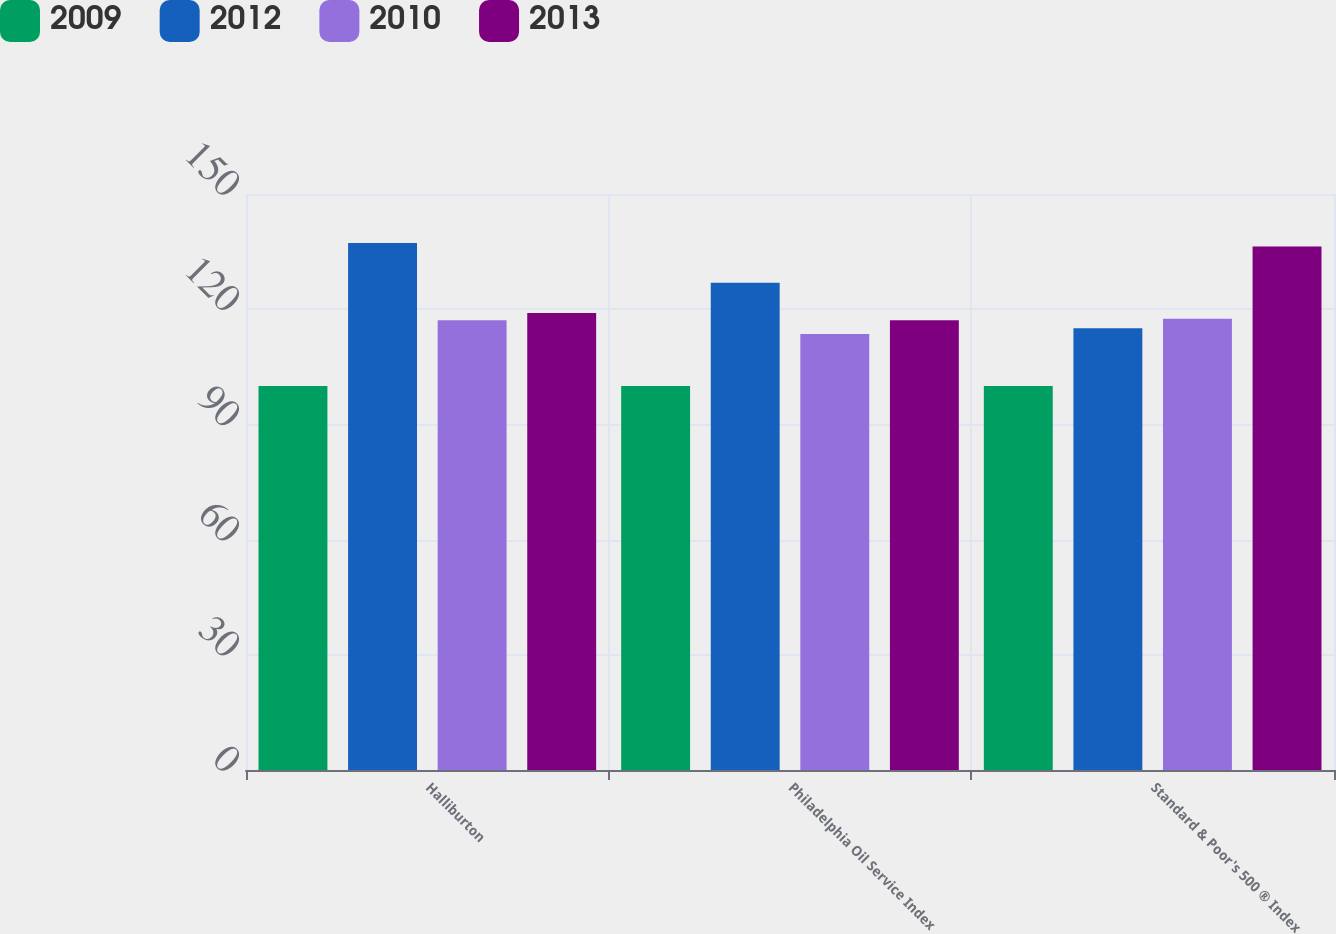Convert chart to OTSL. <chart><loc_0><loc_0><loc_500><loc_500><stacked_bar_chart><ecel><fcel>Halliburton<fcel>Philadelphia Oil Service Index<fcel>Standard & Poor's 500 ® Index<nl><fcel>2009<fcel>100<fcel>100<fcel>100<nl><fcel>2012<fcel>137.25<fcel>126.92<fcel>115.06<nl><fcel>2010<fcel>117.09<fcel>113.53<fcel>117.49<nl><fcel>2013<fcel>119.04<fcel>117.09<fcel>136.3<nl></chart> 